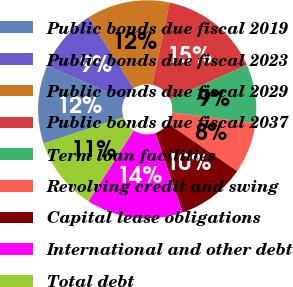Convert chart. <chart><loc_0><loc_0><loc_500><loc_500><pie_chart><fcel>Public bonds due fiscal 2019<fcel>Public bonds due fiscal 2023<fcel>Public bonds due fiscal 2029<fcel>Public bonds due fiscal 2037<fcel>Term loan facilities<fcel>Revolving credit and swing<fcel>Capital lease obligations<fcel>International and other debt<fcel>Total debt<nl><fcel>11.61%<fcel>9.42%<fcel>12.34%<fcel>15.06%<fcel>8.69%<fcel>7.52%<fcel>10.15%<fcel>14.33%<fcel>10.88%<nl></chart> 